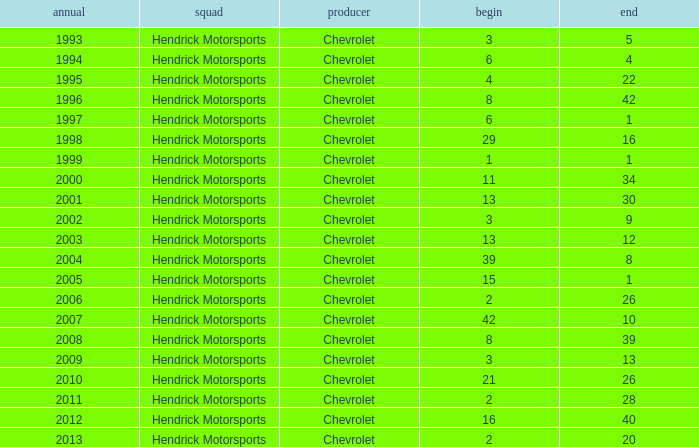What is the number of finishes having a start of 15? 1.0. 